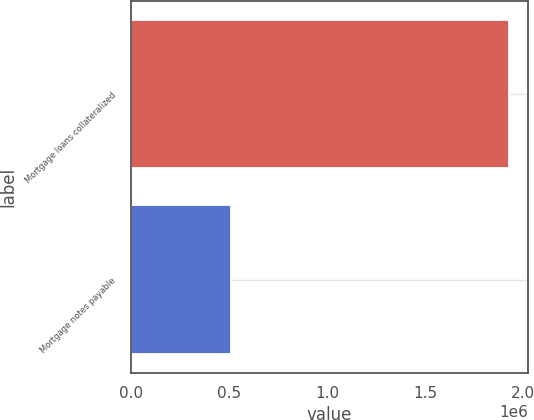Convert chart. <chart><loc_0><loc_0><loc_500><loc_500><bar_chart><fcel>Mortgage loans collateralized<fcel>Mortgage notes payable<nl><fcel>1.92773e+06<fcel>508547<nl></chart> 